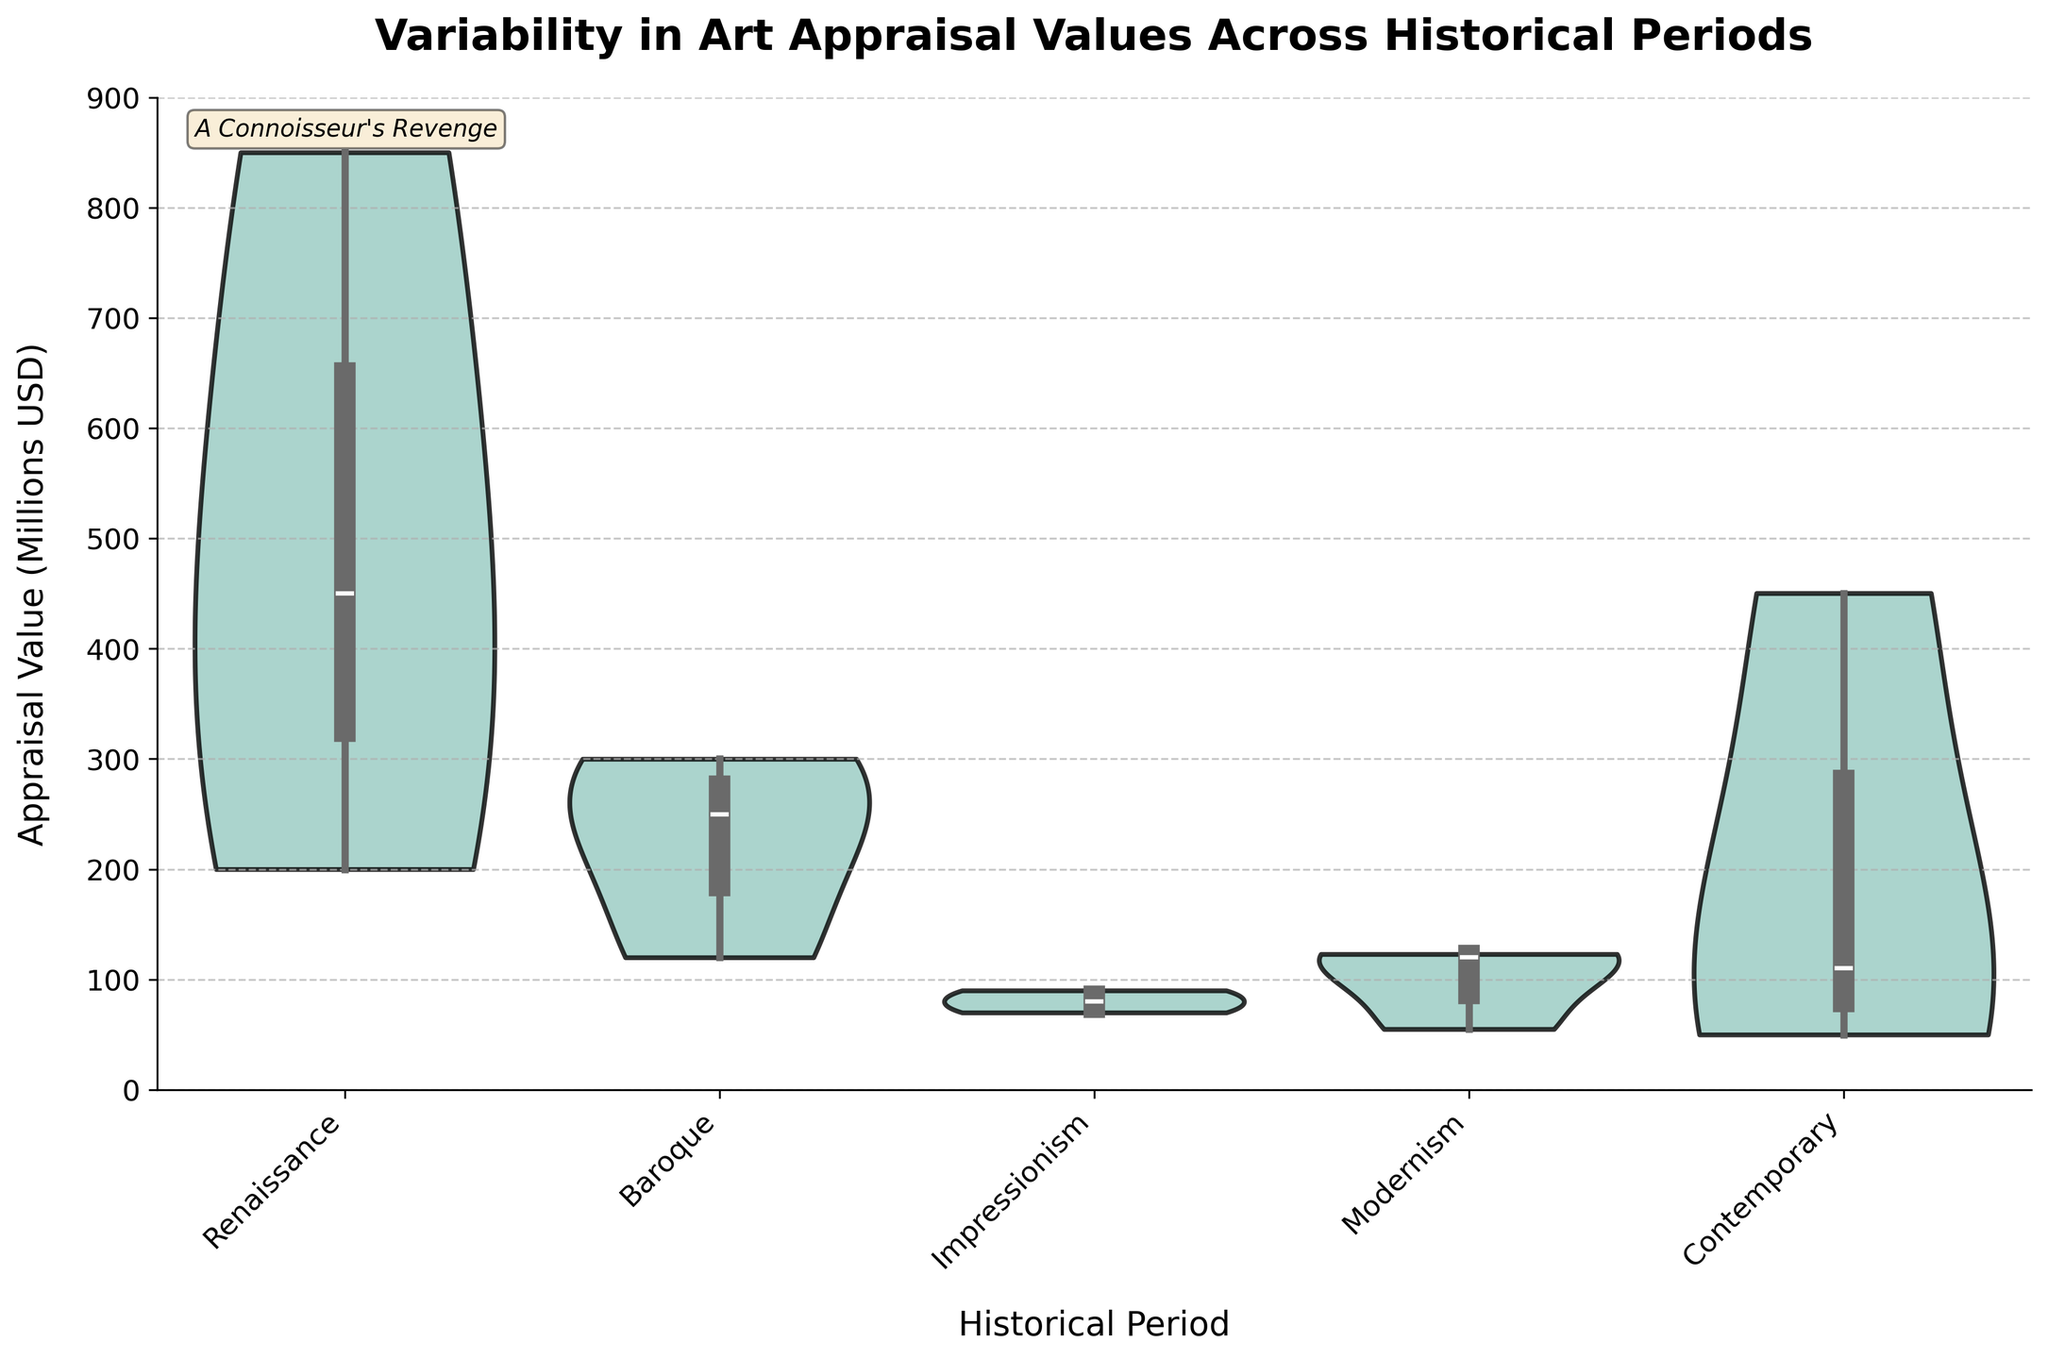What is the title of the figure? The title is usually found at the top of the figure and is meant to give a summary of what the figure is about.
Answer: Variability in Art Appraisal Values Across Historical Periods Which historical period has the highest maximum appraisal value? Look for the highest point on the y-axis within each violin plot and identify the corresponding historical period.
Answer: Renaissance What is the lowest appraisal value in the Contemporary period? Inspect the bottom of the Contemporary violin plot to determine the lowest point.
Answer: $50,000,000 Which historical period shows the widest range of appraisal values? Compare the span (vertical height) of each violin plot to determine which one is the widest.
Answer: Contemporary Are there any periods with more than one peak indicating multiple modes in value distribution? Look at the shape of each violin plot to check for multiple bulges or peaks.
Answer: No Which painting's value skews the overall distribution towards higher appraisal values in the Contemporary period? Identify the painting contributing to the upper tail of the violin plot by looking at the highest appraisal values in the Contemporary period.
Answer: Salvator Mundi How do the appraisal values of the Renaissance period compare with those of the Impressionism period in terms of their median values? Compare the median lines (small white dots or lines inside the violin plots) of the Renaissance and Impressionism periods.
Answer: Renaissance median is higher than Impressionism What's the visual indication used to differentiate inner data details of the violin plots? Check for visual elements such as inner lines or dots representing statistics like quartiles or medians inside the violin plots.
Answer: Box lines and inner dots Can you identify a period where the distribution is relatively uniform and not skewed? Examine the shape of each violin plot to find one that is more symmetrical and uniform in width.
Answer: Modernism 